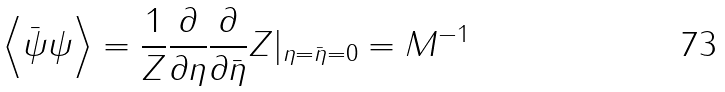<formula> <loc_0><loc_0><loc_500><loc_500>\left \langle { \bar { \psi } } \psi \right \rangle = { \frac { 1 } { Z } } { \frac { \partial } { \partial \eta } } { \frac { \partial } { \partial { \bar { \eta } } } } Z | _ { \eta = { \bar { \eta } } = 0 } = M ^ { - 1 }</formula> 